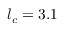Convert formula to latex. <formula><loc_0><loc_0><loc_500><loc_500>l _ { c } = 3 . 1</formula> 